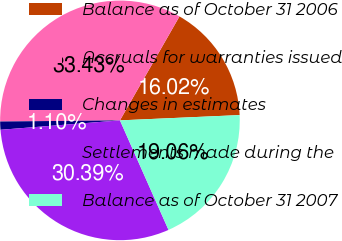<chart> <loc_0><loc_0><loc_500><loc_500><pie_chart><fcel>Balance as of October 31 2006<fcel>Accruals for warranties issued<fcel>Changes in estimates<fcel>Settlements made during the<fcel>Balance as of October 31 2007<nl><fcel>16.02%<fcel>33.43%<fcel>1.1%<fcel>30.39%<fcel>19.06%<nl></chart> 